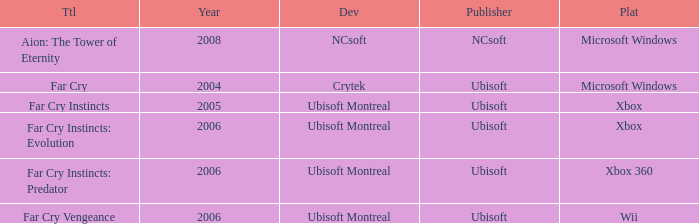Which publisher features far cry as the title? Ubisoft. 